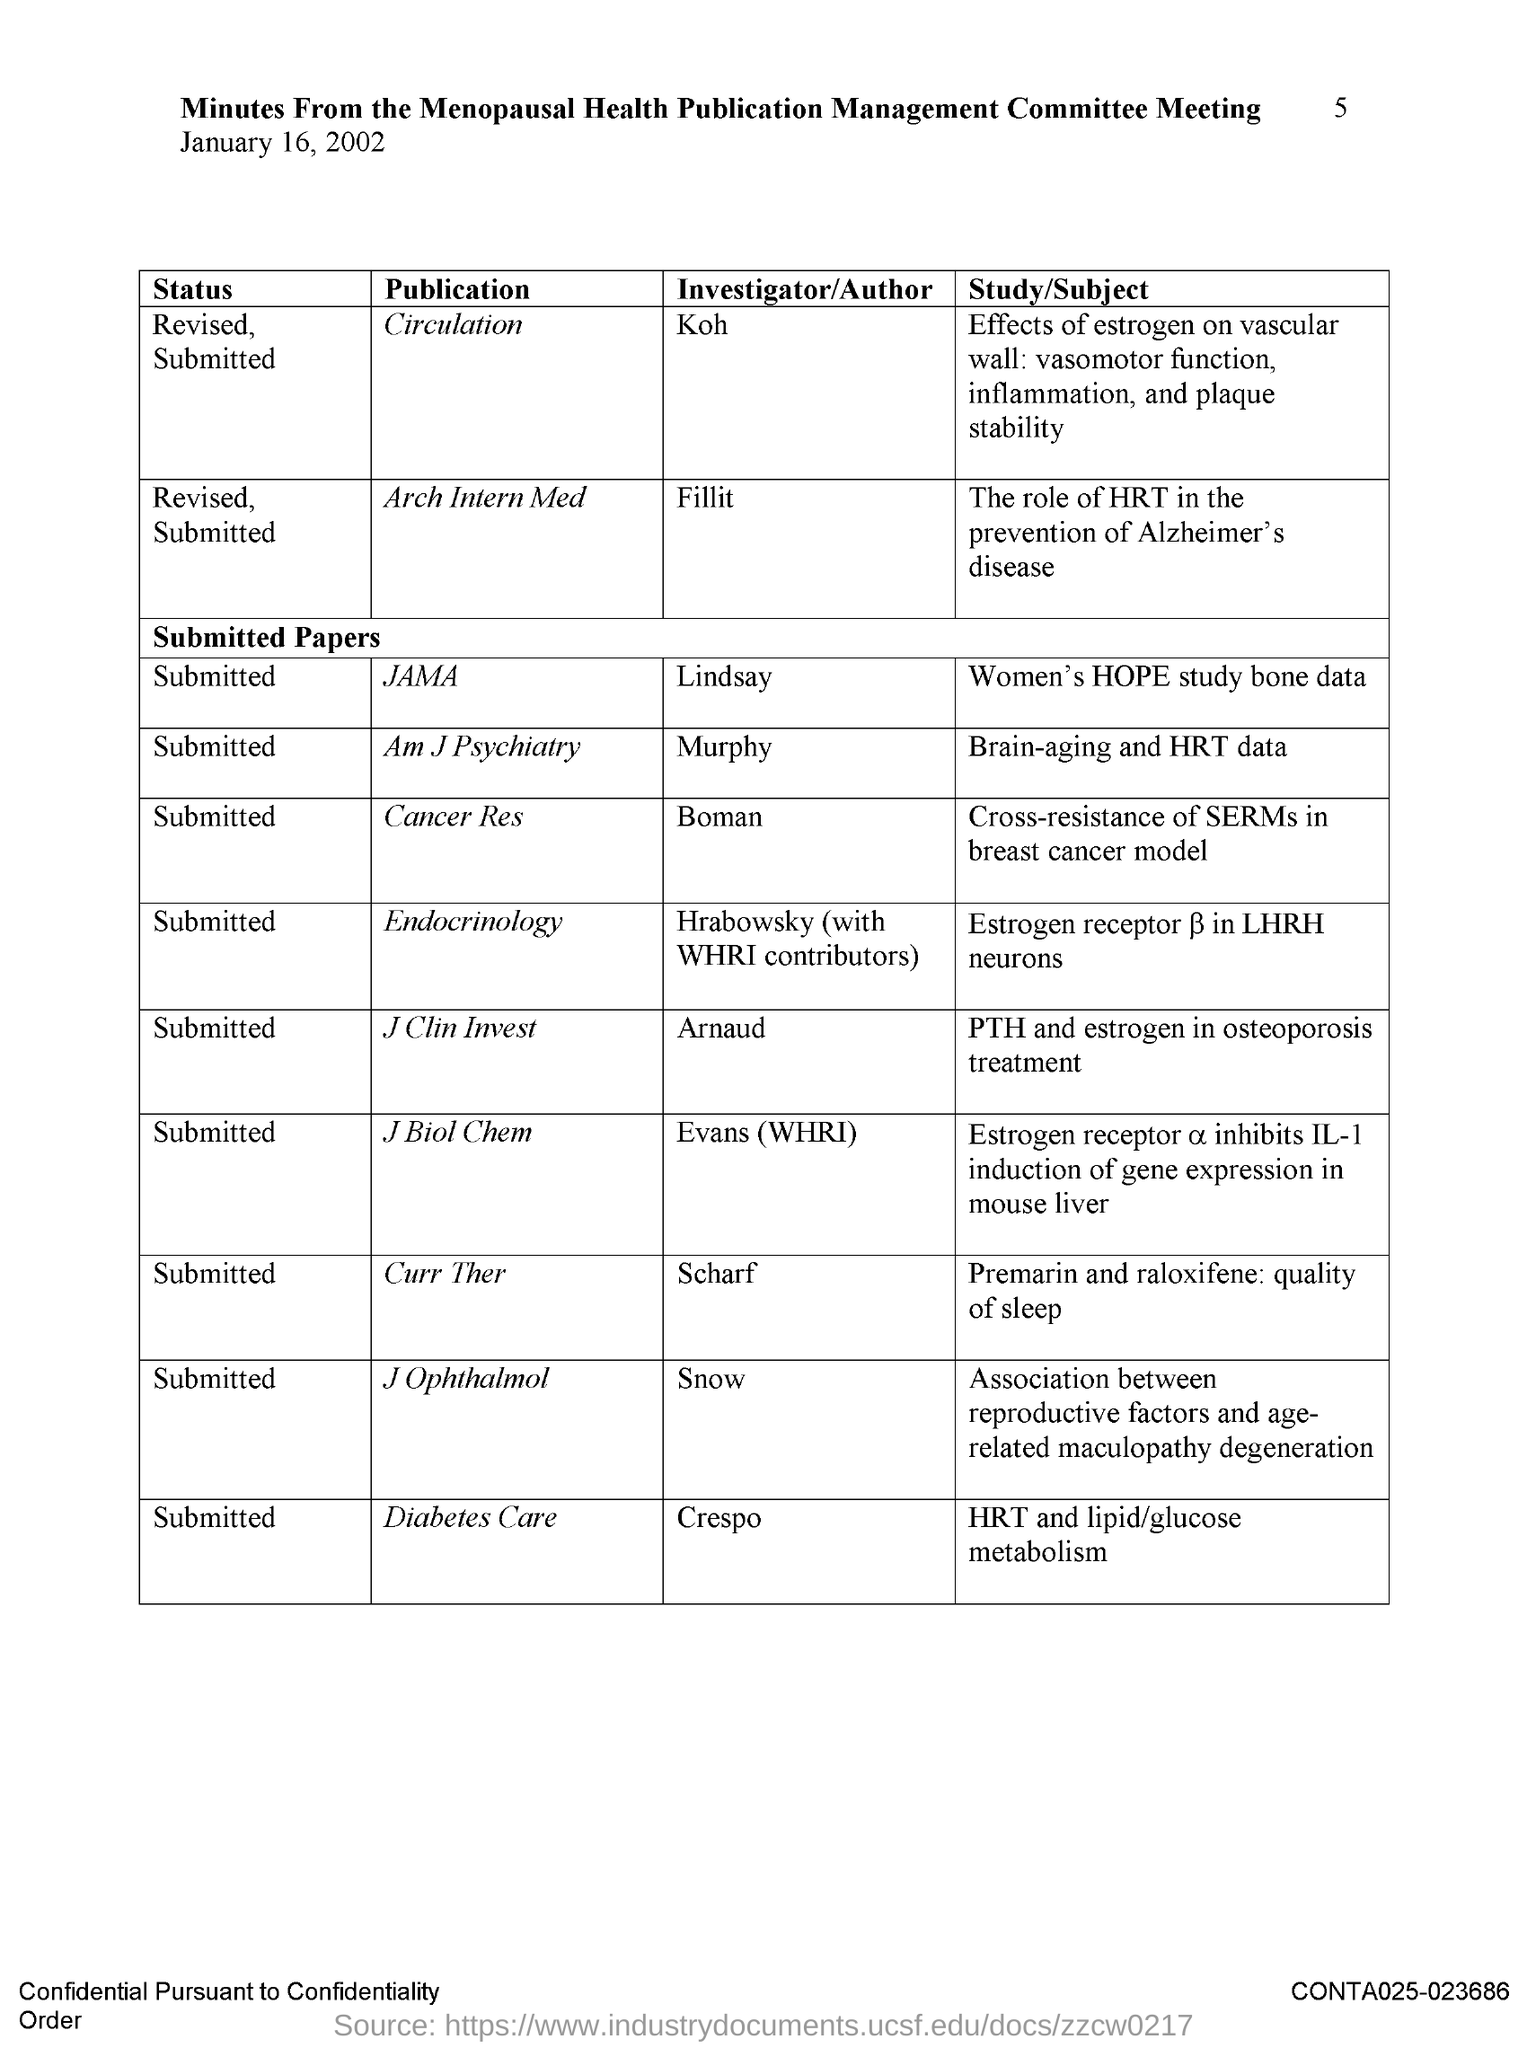What is the name of the investigator/author for the circulation publication ?
Your answer should be compact. Koh. What is the name of the investigator/author for the arch intern med publication ?
Make the answer very short. Fillit. What is the name of the investigator/author for jama publication ?
Your answer should be very brief. Lindsay. What is the name of the investigator/author for am j psychiarty publication ?
Make the answer very short. Murphy. What is the name of the investigator/author for cancer res publication ?
Ensure brevity in your answer.  Boman. For which publication hrabowsky is an investigator/ author?
Offer a terse response. Endocrinology. What is the name of the investigator/author for diabetes care publication ?
Provide a succinct answer. Crespo. What is the name of the investigator/author for curr ther publication ?
Provide a succinct answer. Scharf. 